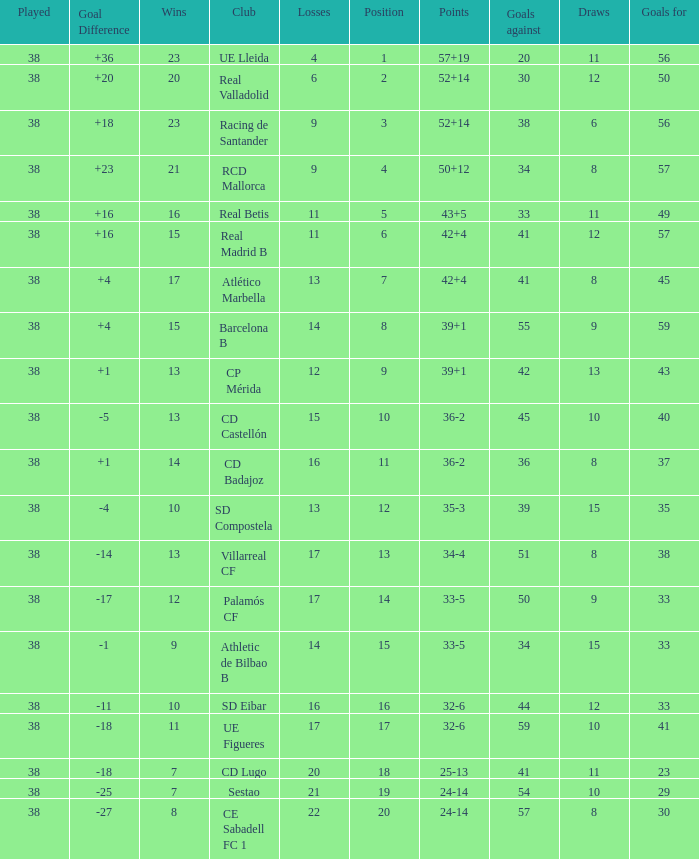What is the lowest position with 32-6 points and less then 59 goals when there are more than 38 played? None. 